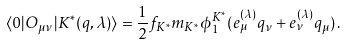<formula> <loc_0><loc_0><loc_500><loc_500>\langle 0 | O _ { \mu \nu } | K ^ { \ast } ( q , \lambda ) \rangle = \frac { 1 } { 2 } f _ { K ^ { * } } m _ { K ^ { * } } \phi _ { 1 } ^ { K ^ { * } } ( e ^ { ( \lambda ) } _ { \mu } q _ { \nu } + e ^ { ( \lambda ) } _ { \nu } q _ { \mu } ) \, .</formula> 